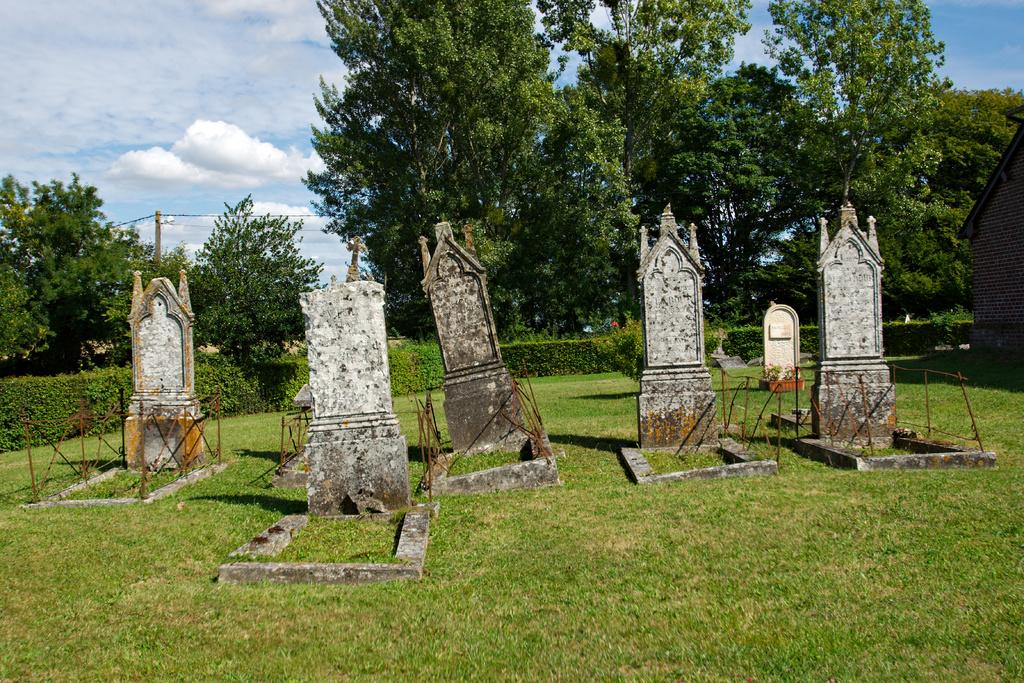What type of location is depicted in the image? The image is of a graveyard. What type of vegetation can be seen in the graveyard? There are plants, grass, and trees in the graveyard. Are there any structures in the graveyard? Yes, there is a house and a pole in the graveyard. What is visible in the sky in the image? The sky is visible in the image. How many servants are attending to the graveyard in the image? There are no servants present in the image; it is a depiction of a graveyard with plants, grass, trees, a house, and a pole. 